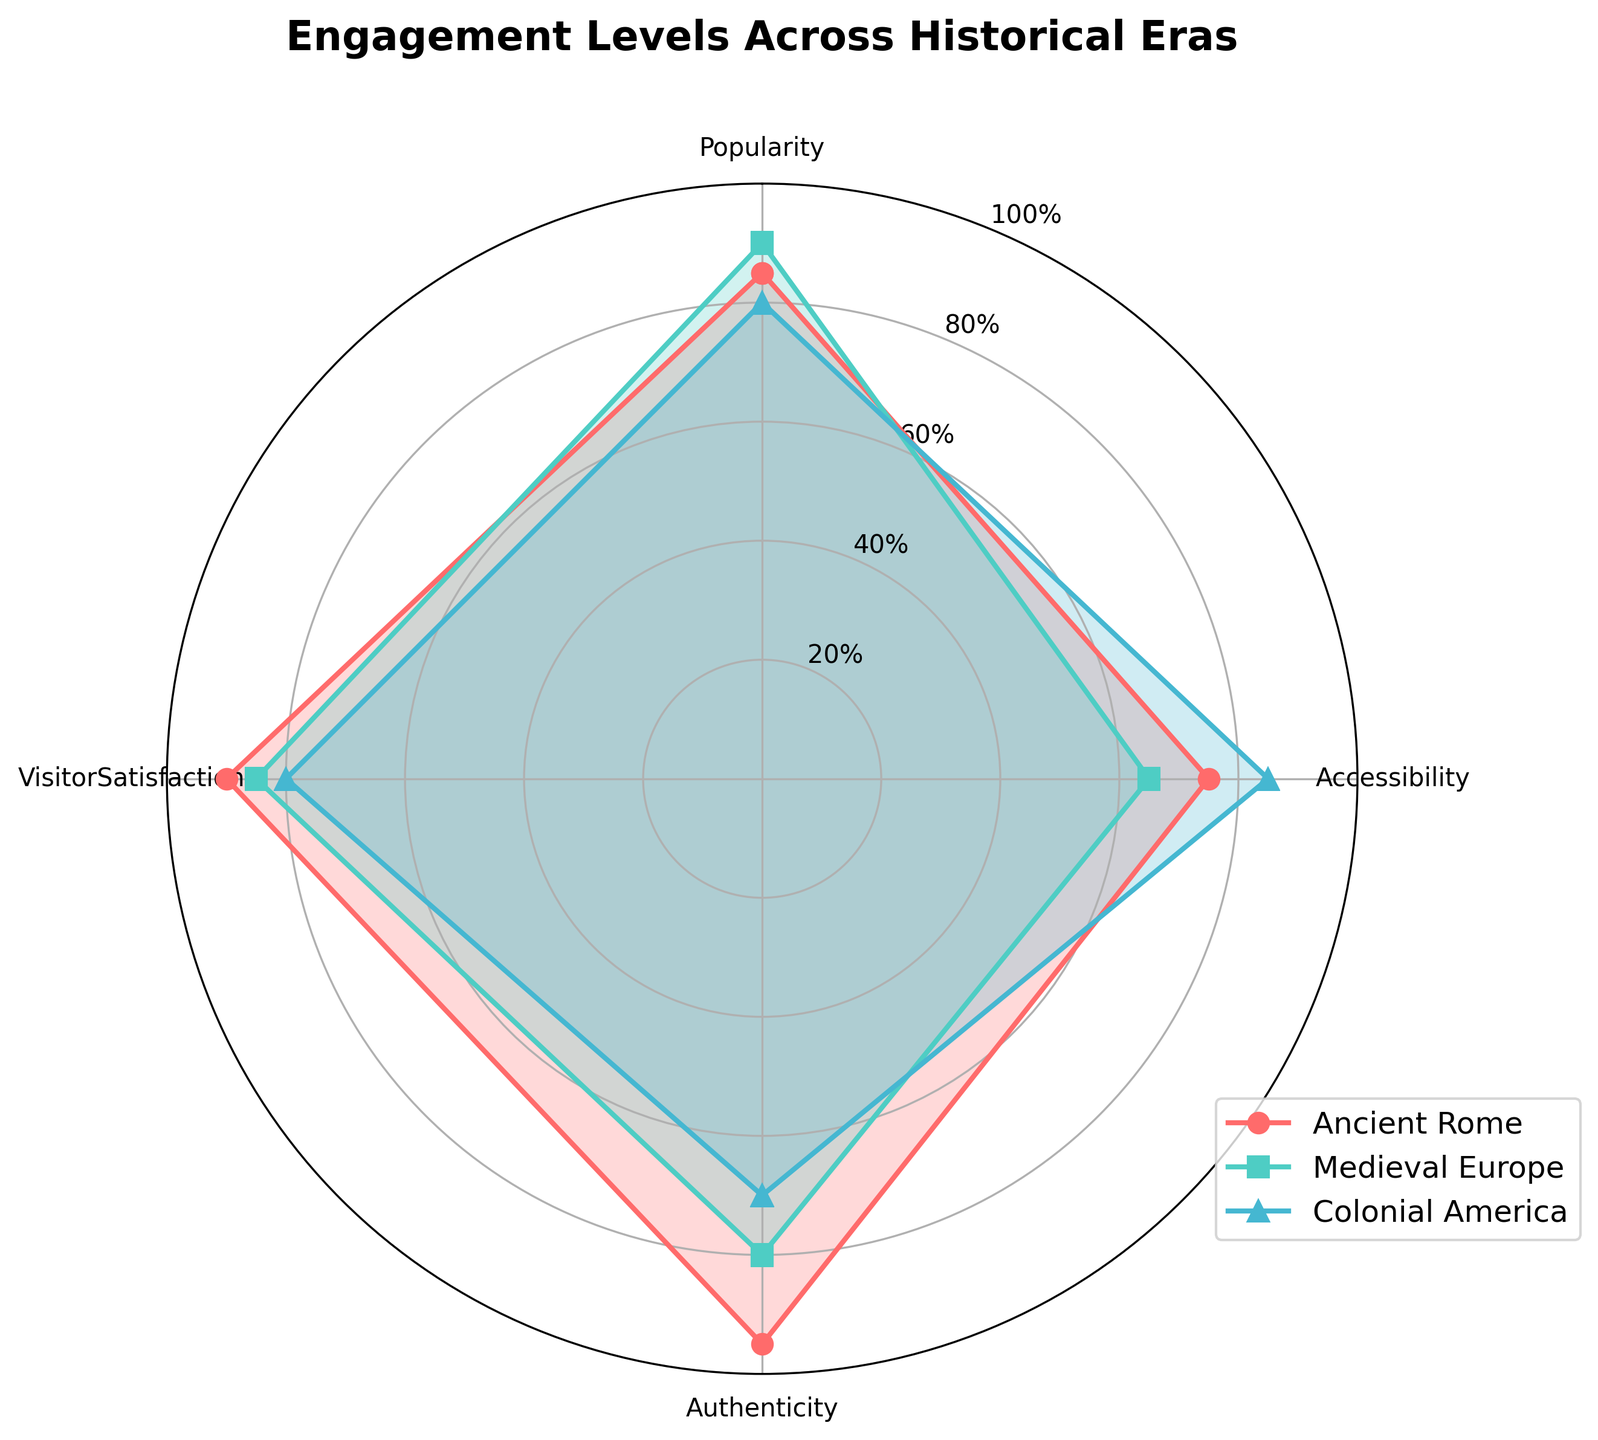What is the title of the radar chart? The title of the radar chart is written at the top of the chart and typically summarizes the main topic of the data being presented.
Answer: Engagement Levels Across Historical Eras Which historical era has the highest Visitor Satisfaction? Visitor Satisfaction can be observed at one of the radar chart's axes, and the values for each era can be compared directly. Ancient Rome has the highest value for Visitor Satisfaction.
Answer: Ancient Rome What is the range of scores for Accessibility across all eras? To find the range, identify the maximum and minimum values for Accessibility across all eras and subtract the minimum from the maximum. The max value is 85 for Colonial America, and the min value is 65 for Medieval Europe. So, the range is 85 - 65.
Answer: 20 Which two categories have the largest difference in scores for Medieval Europe? To find this, locate the scores for each category for Medieval Europe and calculate the differences. The differences are: Popularity vs Accessibility (90 - 65 = 25), Popularity vs Authenticity (90 - 80 = 10), Popularity vs Visitor Satisfaction (90 - 85 = 5), Accessibility vs Authenticity (80 - 65 = 15), Accessibility vs Visitor Satisfaction (85 - 65 = 20), and Authenticity vs Visitor Satisfaction (80 - 85 = 5). The largest difference is between Popularity and Accessibility.
Answer: Popularity and Accessibility How does Colonial America compare to Ancient Rome in terms of Popularity? Compare the points on the radar chart under the Popularity axis. Ancient Rome has a Popularity score of 85, while Colonial America has a score of 80.
Answer: Colonial America's Popularity is 5 points lower than Ancient Rome's What was the average score for Colonial America across all categories? Sum up the scores of all categories for Colonial America (80 + 85 + 70 + 80) and then divide by the number of categories (4). The sum is 315, so the average is 315/4.
Answer: 78.75 Which era had the most consistent scores across all categories? Identify the era where the scores vary the least. Ancient Rome's scores are (85, 75, 95, 90), having a range of 20 (95-75), Medieval Europe's scores are (90, 65, 80, 85), with a range of 25, while Colonial America's scores are (80, 85, 70, 80), with a range of 15. The smallest range indicates the most consistent scores.
Answer: Colonial America Which era had the highest score in Authenticity? Compare the points for Authenticity across all eras. Ancient Rome has a score of 95, Medieval Europe has a score of 80, and Colonial America has a score of 70.
Answer: Ancient Rome What's the difference between the highest and lowest overall scores among the eras in Popularity? Identify the highest and lowest Popularity scores directly from the radar chart. Medieval Europe has the highest at 90, and Colonial America has the lowest at 80. The difference is 90 - 80.
Answer: 10 